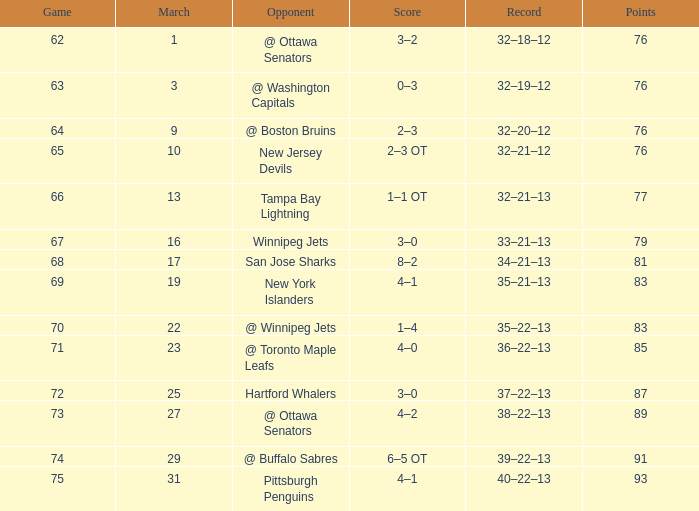How many games have a March of 19, and Points smaller than 83? 0.0. 